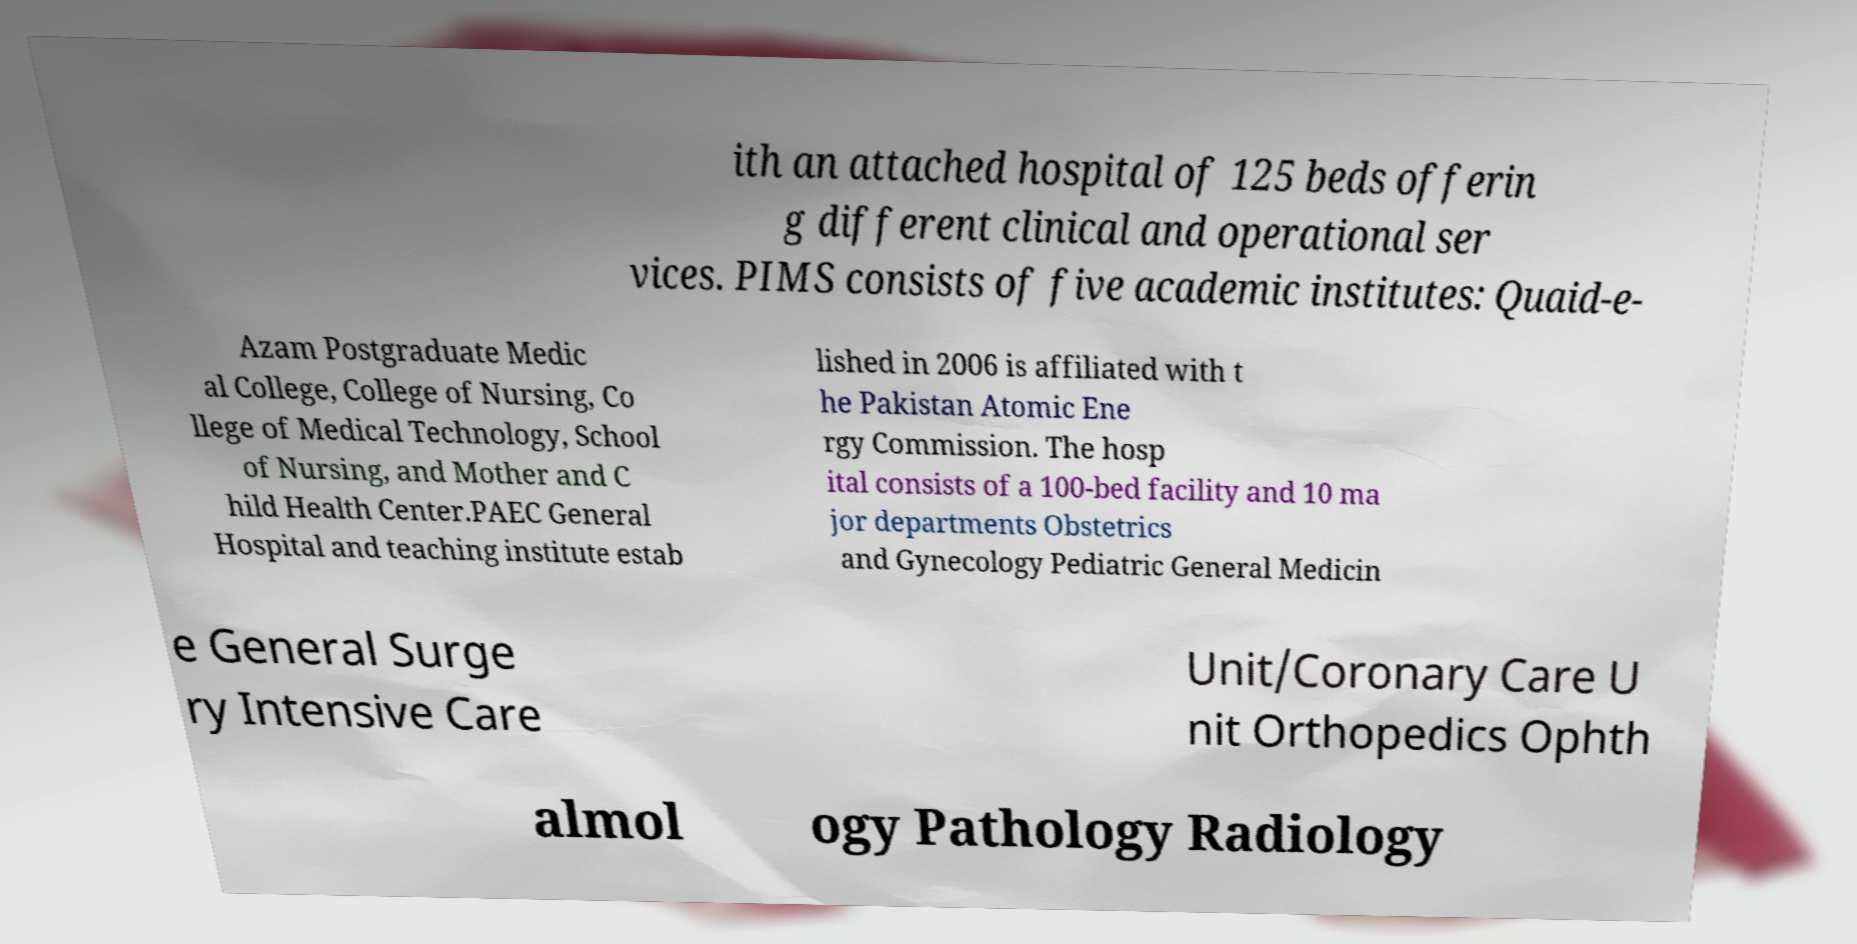Can you accurately transcribe the text from the provided image for me? ith an attached hospital of 125 beds offerin g different clinical and operational ser vices. PIMS consists of five academic institutes: Quaid-e- Azam Postgraduate Medic al College, College of Nursing, Co llege of Medical Technology, School of Nursing, and Mother and C hild Health Center.PAEC General Hospital and teaching institute estab lished in 2006 is affiliated with t he Pakistan Atomic Ene rgy Commission. The hosp ital consists of a 100-bed facility and 10 ma jor departments Obstetrics and Gynecology Pediatric General Medicin e General Surge ry Intensive Care Unit/Coronary Care U nit Orthopedics Ophth almol ogy Pathology Radiology 